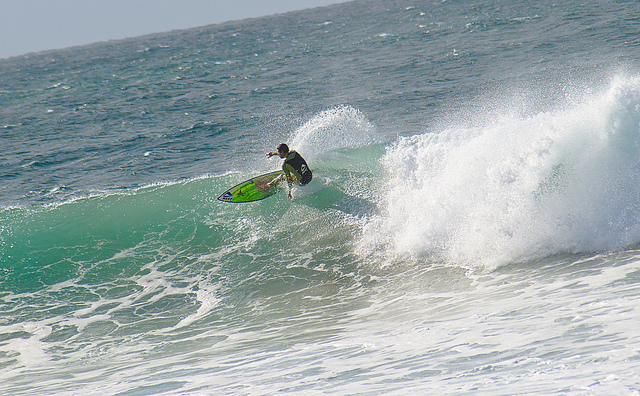How many people are surfing? 1 